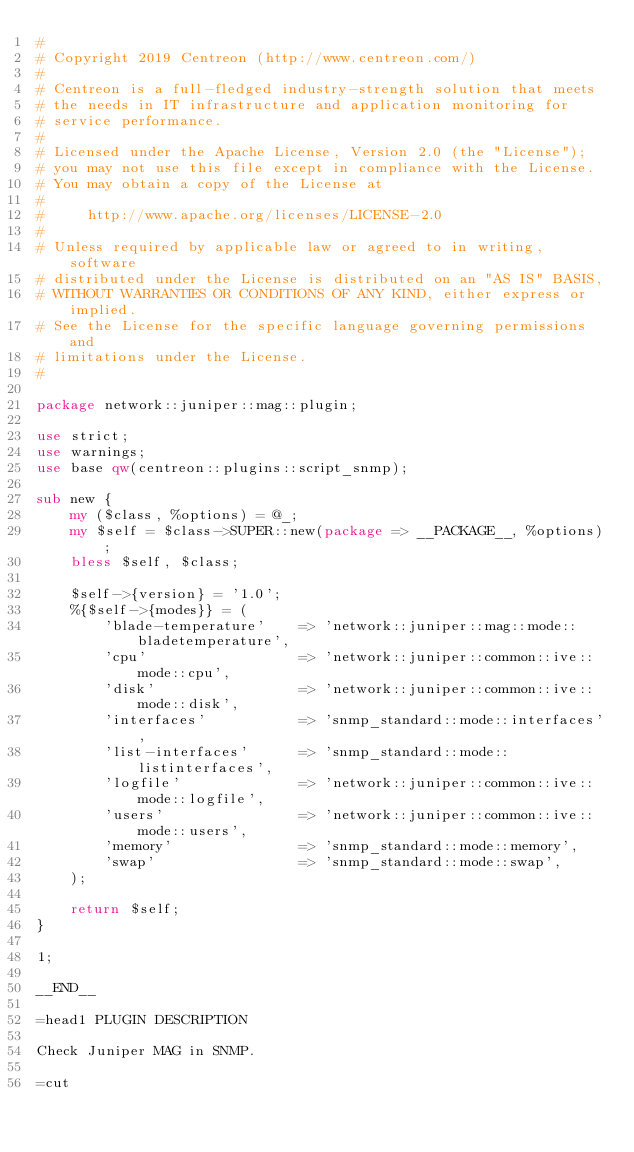<code> <loc_0><loc_0><loc_500><loc_500><_Perl_>#
# Copyright 2019 Centreon (http://www.centreon.com/)
#
# Centreon is a full-fledged industry-strength solution that meets
# the needs in IT infrastructure and application monitoring for
# service performance.
#
# Licensed under the Apache License, Version 2.0 (the "License");
# you may not use this file except in compliance with the License.
# You may obtain a copy of the License at
#
#     http://www.apache.org/licenses/LICENSE-2.0
#
# Unless required by applicable law or agreed to in writing, software
# distributed under the License is distributed on an "AS IS" BASIS,
# WITHOUT WARRANTIES OR CONDITIONS OF ANY KIND, either express or implied.
# See the License for the specific language governing permissions and
# limitations under the License.
#

package network::juniper::mag::plugin;

use strict;
use warnings;
use base qw(centreon::plugins::script_snmp);

sub new {
    my ($class, %options) = @_;
    my $self = $class->SUPER::new(package => __PACKAGE__, %options);
    bless $self, $class;

    $self->{version} = '1.0';
    %{$self->{modes}} = (
        'blade-temperature'    => 'network::juniper::mag::mode::bladetemperature',
        'cpu'                  => 'network::juniper::common::ive::mode::cpu',
        'disk'                 => 'network::juniper::common::ive::mode::disk',
        'interfaces'           => 'snmp_standard::mode::interfaces',
        'list-interfaces'      => 'snmp_standard::mode::listinterfaces',
        'logfile'              => 'network::juniper::common::ive::mode::logfile',
        'users'                => 'network::juniper::common::ive::mode::users',
        'memory'               => 'snmp_standard::mode::memory',
        'swap'                 => 'snmp_standard::mode::swap',
    );

    return $self;
}

1;

__END__

=head1 PLUGIN DESCRIPTION

Check Juniper MAG in SNMP.

=cut
</code> 